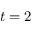<formula> <loc_0><loc_0><loc_500><loc_500>t = 2</formula> 